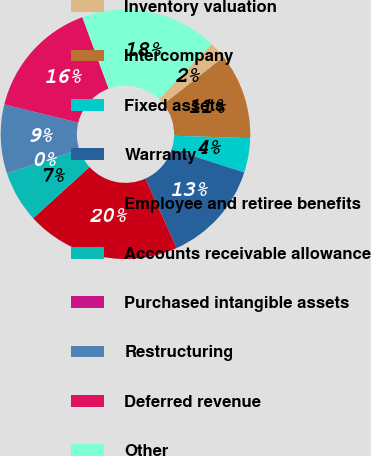Convert chart. <chart><loc_0><loc_0><loc_500><loc_500><pie_chart><fcel>Inventory valuation<fcel>Intercompany<fcel>Fixed assets<fcel>Warranty<fcel>Employee and retiree benefits<fcel>Accounts receivable allowance<fcel>Purchased intangible assets<fcel>Restructuring<fcel>Deferred revenue<fcel>Other<nl><fcel>2.25%<fcel>11.11%<fcel>4.46%<fcel>13.32%<fcel>19.97%<fcel>6.68%<fcel>0.03%<fcel>8.89%<fcel>15.54%<fcel>17.75%<nl></chart> 